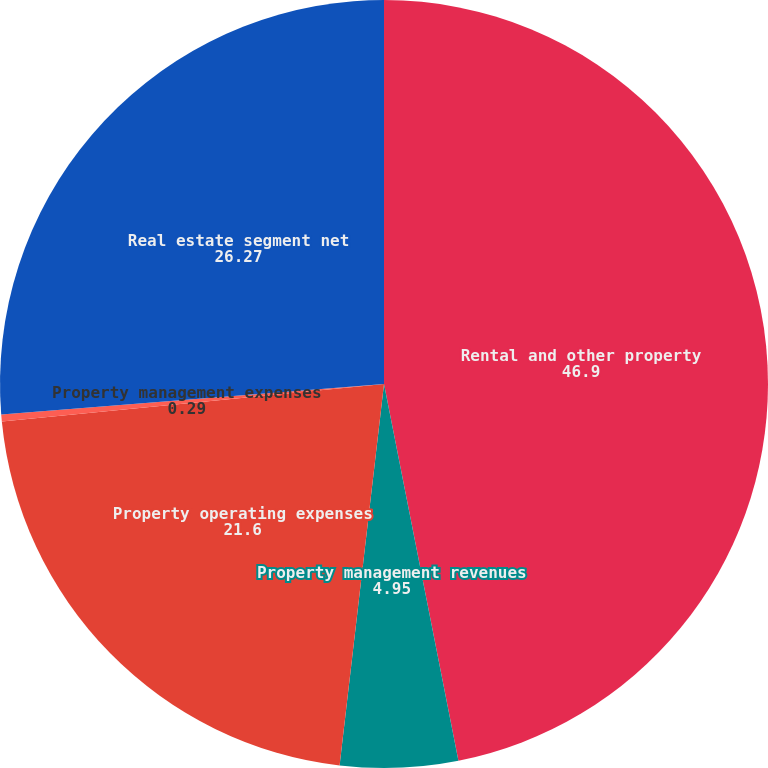Convert chart. <chart><loc_0><loc_0><loc_500><loc_500><pie_chart><fcel>Rental and other property<fcel>Property management revenues<fcel>Property operating expenses<fcel>Property management expenses<fcel>Real estate segment net<nl><fcel>46.9%<fcel>4.95%<fcel>21.6%<fcel>0.29%<fcel>26.27%<nl></chart> 